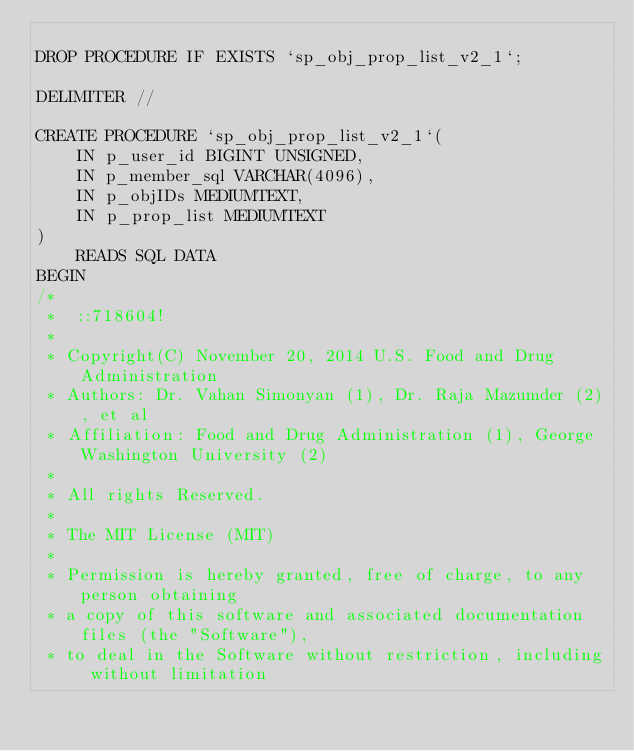<code> <loc_0><loc_0><loc_500><loc_500><_SQL_>
DROP PROCEDURE IF EXISTS `sp_obj_prop_list_v2_1`;

DELIMITER //

CREATE PROCEDURE `sp_obj_prop_list_v2_1`(
    IN p_user_id BIGINT UNSIGNED,
    IN p_member_sql VARCHAR(4096),
    IN p_objIDs MEDIUMTEXT,
    IN p_prop_list MEDIUMTEXT
)
    READS SQL DATA
BEGIN
/*
 *  ::718604!
 * 
 * Copyright(C) November 20, 2014 U.S. Food and Drug Administration
 * Authors: Dr. Vahan Simonyan (1), Dr. Raja Mazumder (2), et al
 * Affiliation: Food and Drug Administration (1), George Washington University (2)
 * 
 * All rights Reserved.
 * 
 * The MIT License (MIT)
 * 
 * Permission is hereby granted, free of charge, to any person obtaining
 * a copy of this software and associated documentation files (the "Software"),
 * to deal in the Software without restriction, including without limitation</code> 